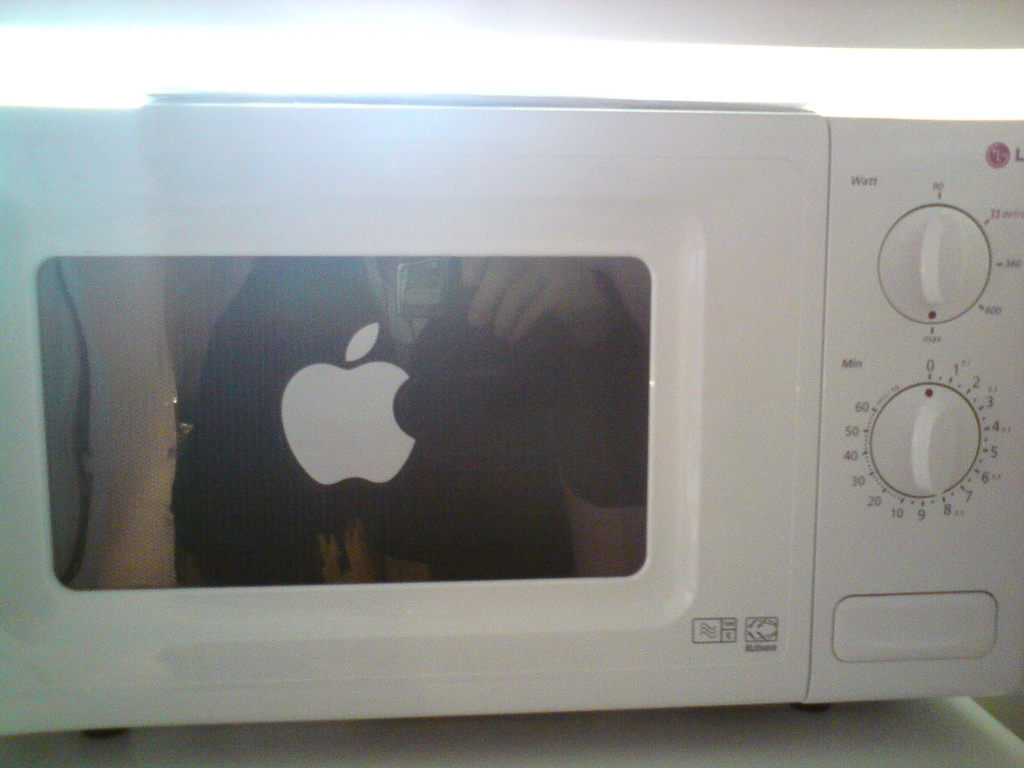Why might someone put an Apple logo sticker on a microwave oven? It could be a humorous or creative expression, perhaps signaling the owner's appreciation for Apple products, or simply making a playful statement by mixing technology brands in unexpected ways. 